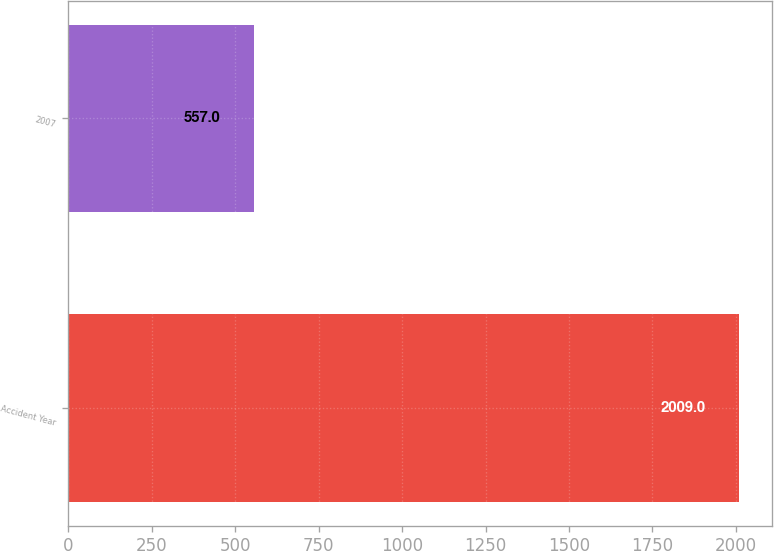<chart> <loc_0><loc_0><loc_500><loc_500><bar_chart><fcel>Accident Year<fcel>2007<nl><fcel>2009<fcel>557<nl></chart> 